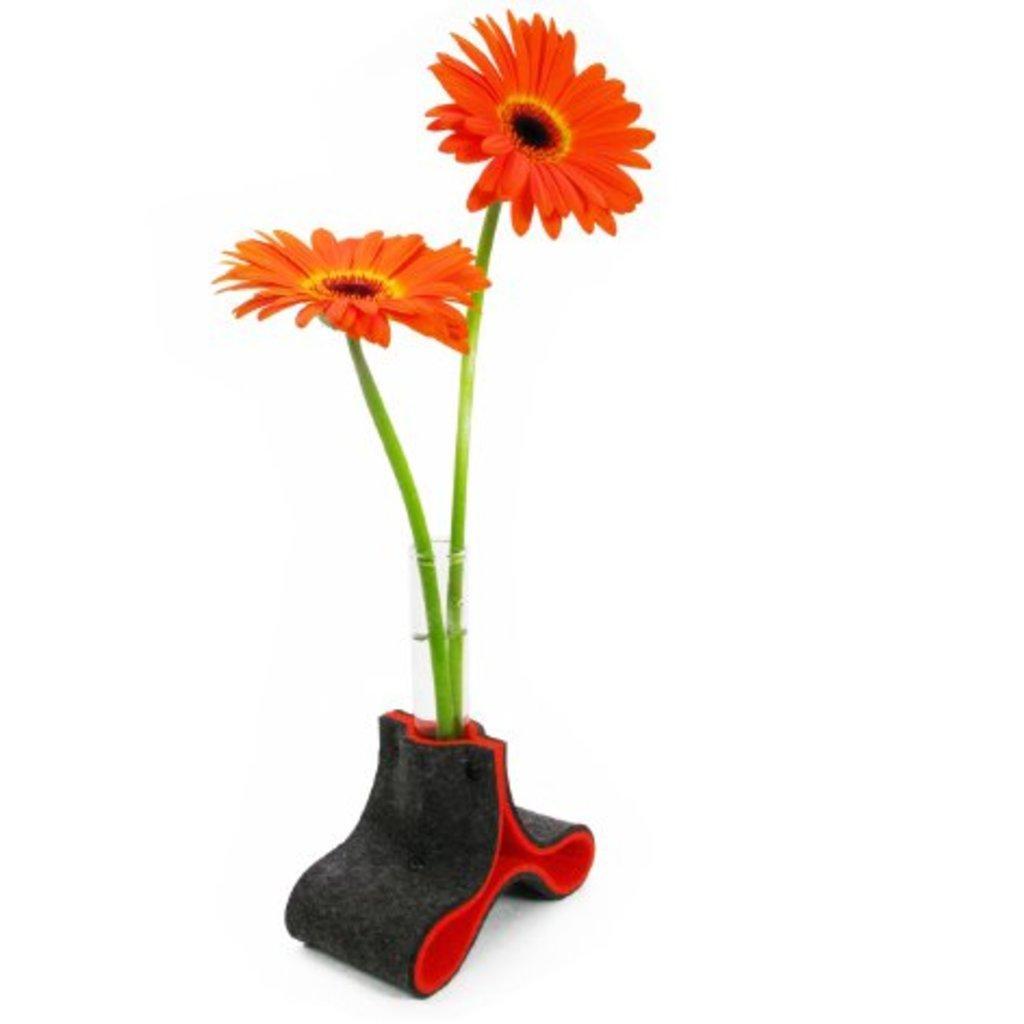How would you summarize this image in a sentence or two? In this image we can see a two orange color flowers in a vase on the surface. 